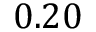<formula> <loc_0><loc_0><loc_500><loc_500>0 . 2 0</formula> 